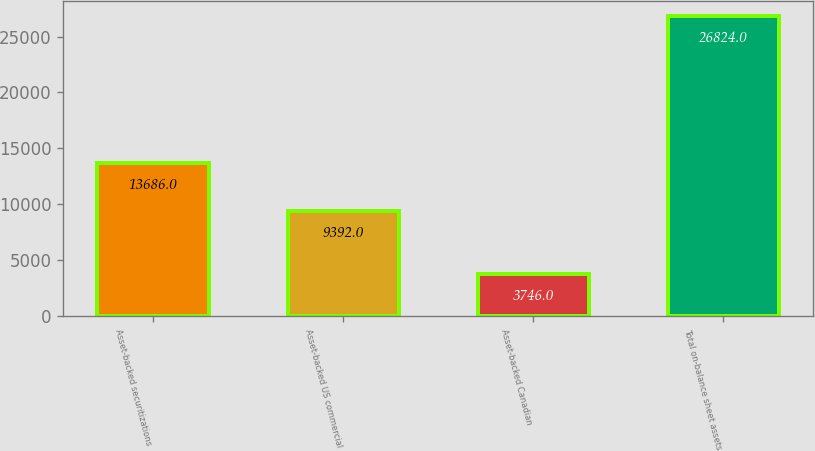<chart> <loc_0><loc_0><loc_500><loc_500><bar_chart><fcel>Asset-backed securitizations<fcel>Asset-backed US commercial<fcel>Asset-backed Canadian<fcel>Total on-balance sheet assets<nl><fcel>13686<fcel>9392<fcel>3746<fcel>26824<nl></chart> 